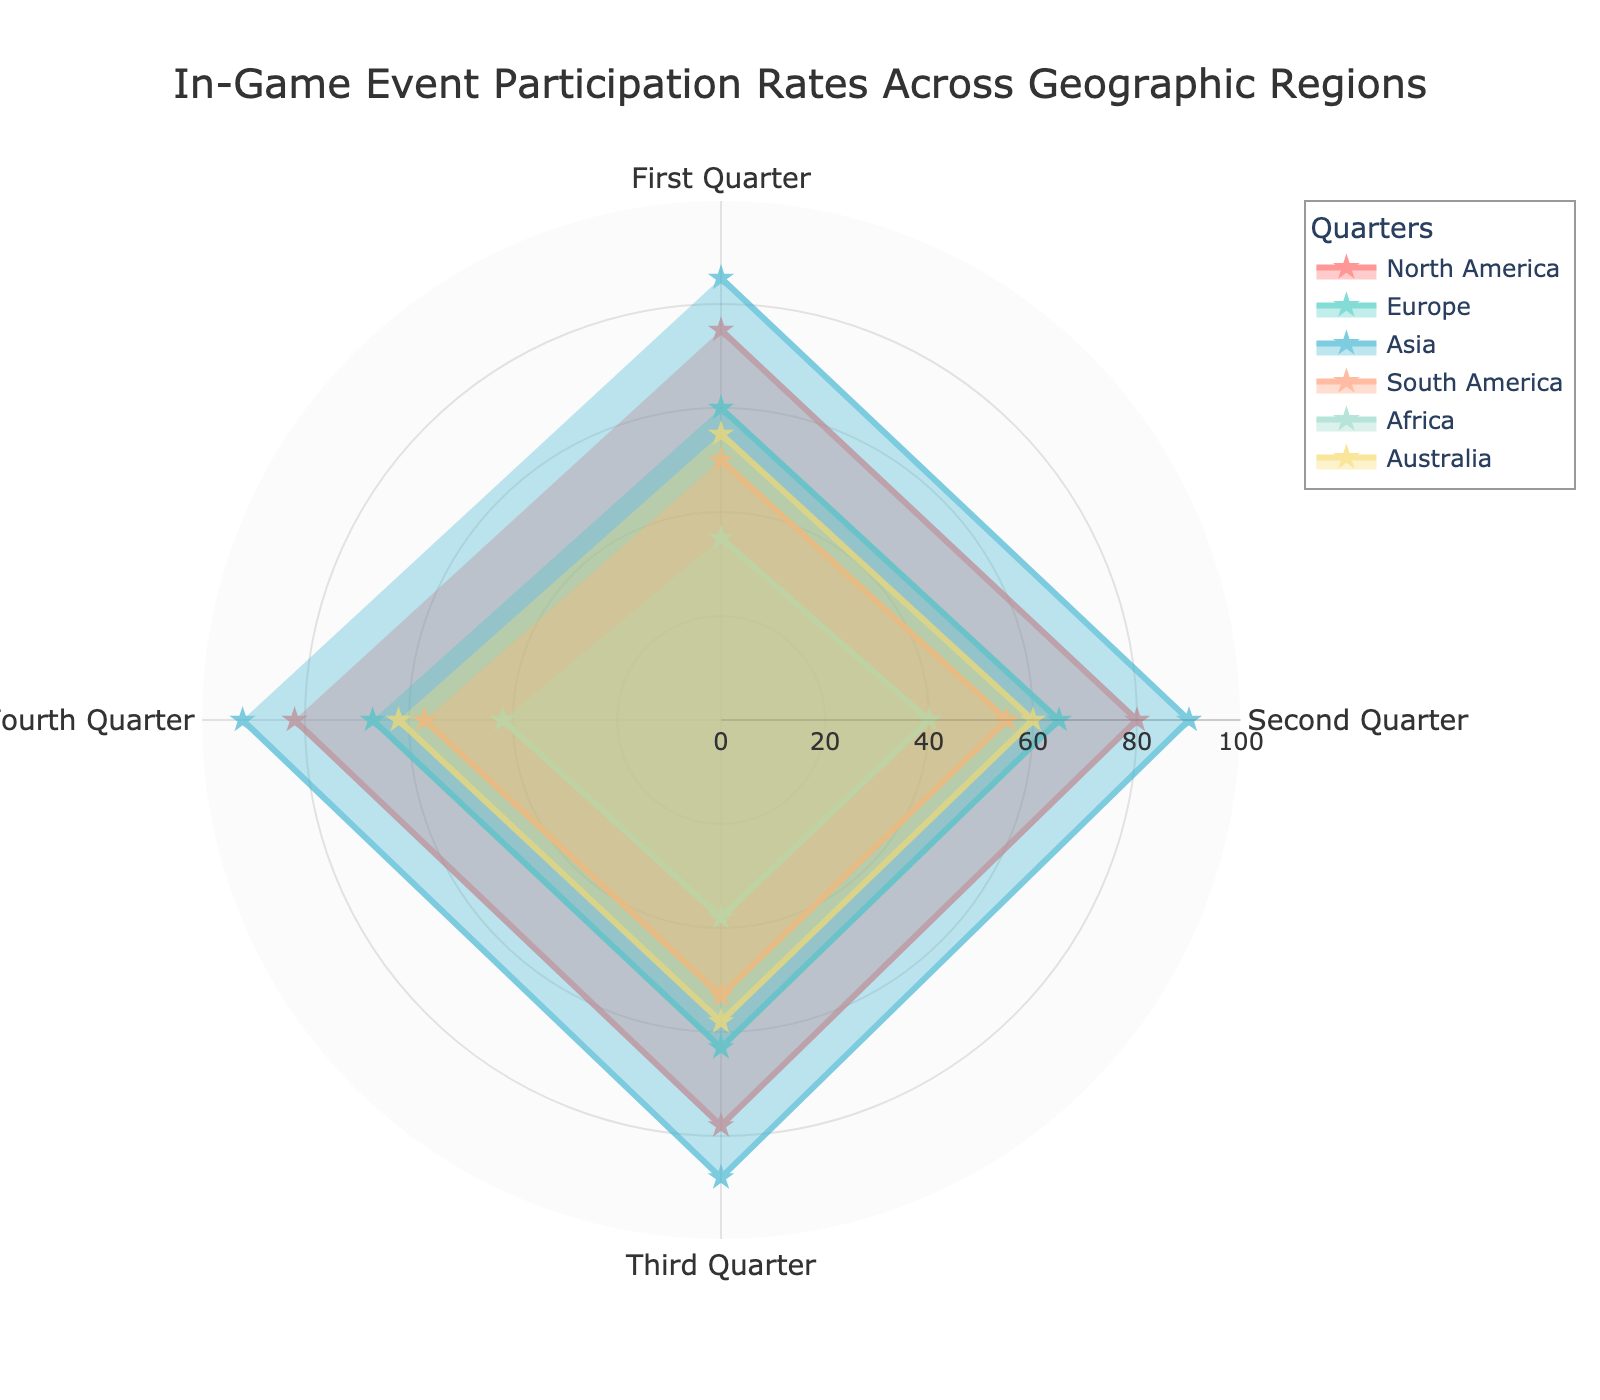What's the title of the chart? The title is usually found at the top of the chart. In this case, the title is displayed as "In-Game Event Participation Rates Across Geographic Regions".
Answer: In-Game Event Participation Rates Across Geographic Regions Which region has the highest participation rate in the fourth quarter? Look for the line representing the fourth quarter and identify the region where the line reaches its highest point. For the fourth quarter, the highest value is 92 in Asia.
Answer: Asia What is the range of the radial axis? The radial axis range can be identified by looking at the values on the axis. Here, it ranges from 0 to 100.
Answer: 0 to 100 Compare the participation rate between North America and Europe in the second quarter. Which is higher and by how much? Identify the values for North America and Europe in the second quarter. North America's rate is 80, and Europe's rate is 65. Subtract 65 from 80.
Answer: North America by 15 What was the participation rate in Africa for each quarter, and what is the average rate across the year? Extract the values for Africa in all quarters (35, 40, 38, 42). Sum them up and divide by the number of quarters (four). (35 + 40 + 38 + 42) / 4 = 38.75.
Answer: 38.75 How did the participation rate in Australia change from the first quarter to the fourth quarter? Note the values for Australia in the first (55) and fourth quarter (62). Find the change by subtracting the first quarter value from the fourth quarter value. 62 - 55 = 7.
Answer: Increased by 7 Which quarter shows the lowest average participation rate across all regions? Calculate the average rate for each quarter by summing the rates for all regions and dividing by the number of regions (6). The averages are: First Quarter: (75+60+85+50+35+55)/6 = 60; Second Quarter: (80+65+90+55+40+60)/6 = 65; Third Quarter: (78+63+88+53+38+58)/6 = 63; Fourth Quarter: (82+67+92+57+42+62)/6 = 67. The lowest average is for the First Quarter.
Answer: First Quarter What is the unique visualization characteristic used for each quarter's data in the chart? The chart uses different colors and symbols (star markers) to differentiate each quarter's data.
Answer: Colors and star markers Which two regions have the smallest difference in participation rates during the third quarter? Identify the values for each region in the third quarter and calculate the differences between each pair. The smallest difference is between South America (53) and Australia (58). Difference is 5.
Answer: South America and Australia In which quarter did North America see the highest participation rate, and what was the rate? By examining the values for North America in each quarter, the highest rate is observed in the fourth quarter at 82.
Answer: Fourth quarter, 82 